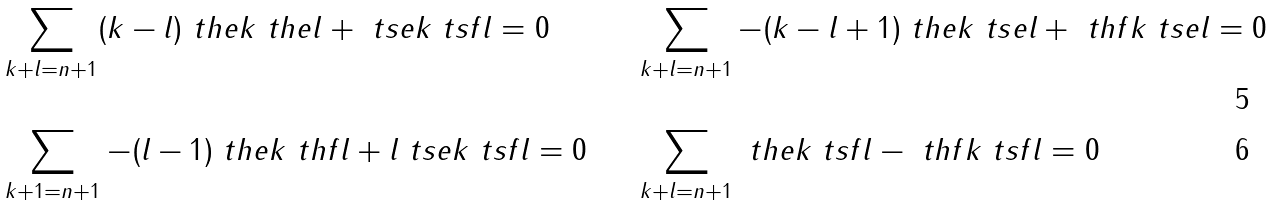Convert formula to latex. <formula><loc_0><loc_0><loc_500><loc_500>& \sum _ { k + l = n + 1 } ( k - l ) \ t h e k \ t h e l + \ t s e k \ t s f l = 0 & \quad & \sum _ { k + l = n + 1 } - ( k - l + 1 ) \ t h e k \ t s e l + \ t h f k \ t s e l = 0 \\ & \sum _ { k + 1 = n + 1 } - ( l - 1 ) \ t h e k \ t h f l + l \ t s e k \ t s f l = 0 & \quad & \sum _ { k + l = n + 1 } \ t h e k \ t s f l - \ t h f k \ t s f l = 0</formula> 